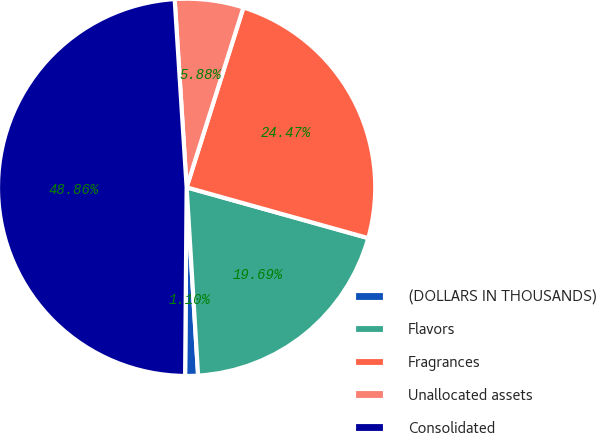<chart> <loc_0><loc_0><loc_500><loc_500><pie_chart><fcel>(DOLLARS IN THOUSANDS)<fcel>Flavors<fcel>Fragrances<fcel>Unallocated assets<fcel>Consolidated<nl><fcel>1.1%<fcel>19.69%<fcel>24.47%<fcel>5.88%<fcel>48.86%<nl></chart> 